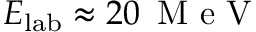Convert formula to latex. <formula><loc_0><loc_0><loc_500><loc_500>E _ { l a b } \approx 2 0 \, M e V</formula> 